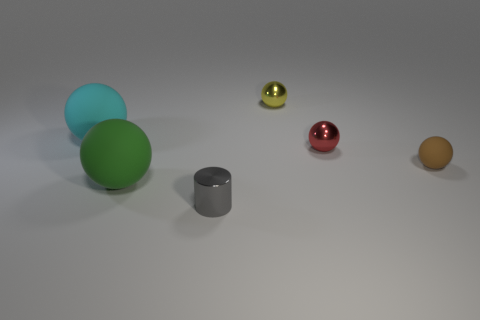There is a small rubber thing; does it have the same color as the tiny metal object in front of the small red metallic sphere?
Your answer should be very brief. No. What number of gray things are tiny metallic spheres or tiny rubber objects?
Offer a terse response. 0. There is a gray shiny object; what shape is it?
Offer a terse response. Cylinder. What number of other things are the same shape as the green object?
Your answer should be compact. 4. What color is the big thing behind the tiny red shiny thing?
Keep it short and to the point. Cyan. Is the material of the small yellow sphere the same as the red object?
Offer a terse response. Yes. What number of objects are tiny yellow shiny objects or objects that are behind the small gray metal cylinder?
Provide a succinct answer. 5. What shape is the small shiny object that is to the right of the yellow thing?
Your response must be concise. Sphere. Does the sphere in front of the brown matte sphere have the same size as the small gray metallic object?
Your answer should be very brief. No. There is a big object that is behind the large green ball; is there a brown matte ball that is behind it?
Your answer should be very brief. No. 